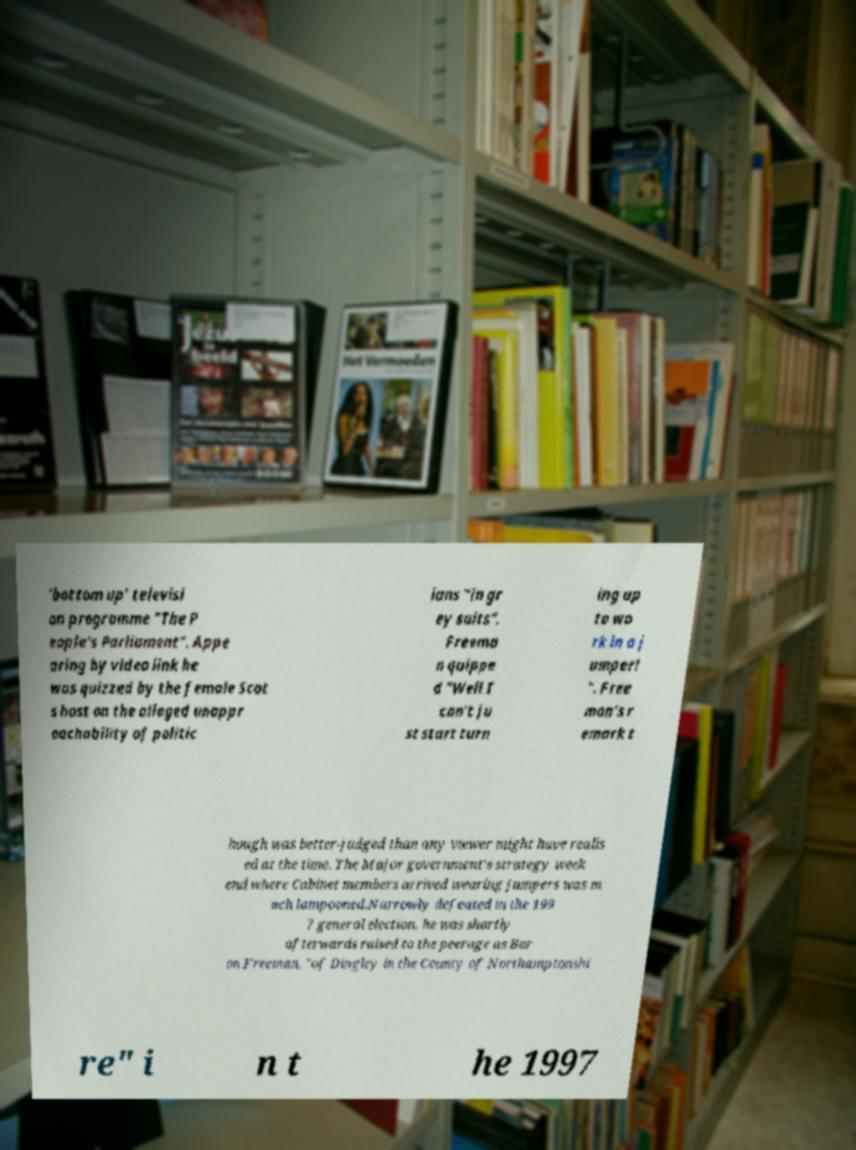Could you extract and type out the text from this image? 'bottom up' televisi on programme "The P eople's Parliament". Appe aring by video link he was quizzed by the female Scot s host on the alleged unappr oachability of politic ians "in gr ey suits". Freema n quippe d "Well I can't ju st start turn ing up to wo rk in a j umper! ". Free man's r emark t hough was better-judged than any viewer might have realis ed at the time. The Major government's strategy week end where Cabinet members arrived wearing jumpers was m uch lampooned.Narrowly defeated in the 199 7 general election, he was shortly afterwards raised to the peerage as Bar on Freeman, "of Dingley in the County of Northamptonshi re" i n t he 1997 